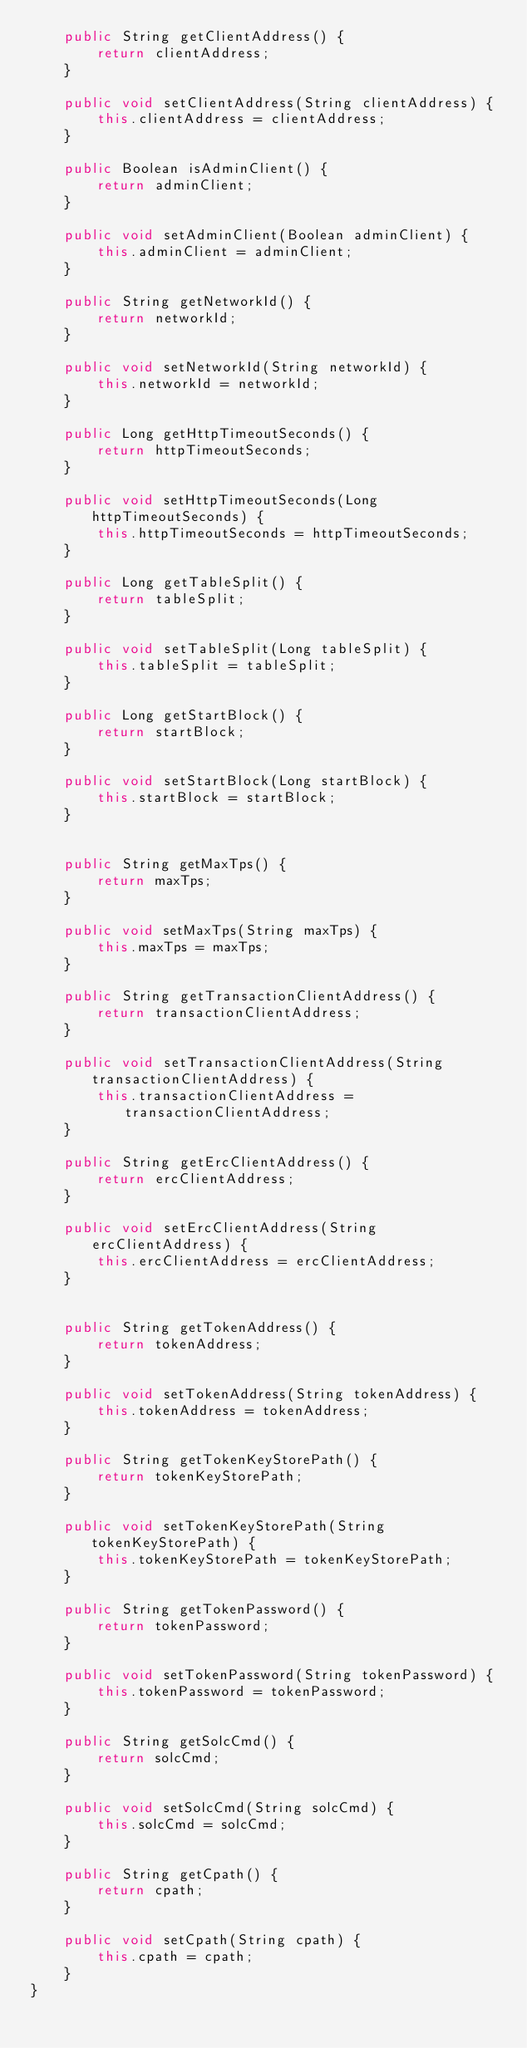<code> <loc_0><loc_0><loc_500><loc_500><_Java_>    public String getClientAddress() {
        return clientAddress;
    }

    public void setClientAddress(String clientAddress) {
        this.clientAddress = clientAddress;
    }

    public Boolean isAdminClient() {
        return adminClient;
    }

    public void setAdminClient(Boolean adminClient) {
        this.adminClient = adminClient;
    }

    public String getNetworkId() {
        return networkId;
    }

    public void setNetworkId(String networkId) {
        this.networkId = networkId;
    }

    public Long getHttpTimeoutSeconds() {
        return httpTimeoutSeconds;
    }

    public void setHttpTimeoutSeconds(Long httpTimeoutSeconds) {
        this.httpTimeoutSeconds = httpTimeoutSeconds;
    }

    public Long getTableSplit() {
        return tableSplit;
    }

    public void setTableSplit(Long tableSplit) {
        this.tableSplit = tableSplit;
    }

    public Long getStartBlock() {
        return startBlock;
    }

    public void setStartBlock(Long startBlock) {
        this.startBlock = startBlock;
    }


    public String getMaxTps() {
        return maxTps;
    }

    public void setMaxTps(String maxTps) {
        this.maxTps = maxTps;
    }

    public String getTransactionClientAddress() {
        return transactionClientAddress;
    }

    public void setTransactionClientAddress(String transactionClientAddress) {
        this.transactionClientAddress = transactionClientAddress;
    }

    public String getErcClientAddress() {
        return ercClientAddress;
    }

    public void setErcClientAddress(String ercClientAddress) {
        this.ercClientAddress = ercClientAddress;
    }


    public String getTokenAddress() {
        return tokenAddress;
    }

    public void setTokenAddress(String tokenAddress) {
        this.tokenAddress = tokenAddress;
    }

    public String getTokenKeyStorePath() {
        return tokenKeyStorePath;
    }

    public void setTokenKeyStorePath(String tokenKeyStorePath) {
        this.tokenKeyStorePath = tokenKeyStorePath;
    }

    public String getTokenPassword() {
        return tokenPassword;
    }

    public void setTokenPassword(String tokenPassword) {
        this.tokenPassword = tokenPassword;
    }

    public String getSolcCmd() {
        return solcCmd;
    }

    public void setSolcCmd(String solcCmd) {
        this.solcCmd = solcCmd;
    }

    public String getCpath() {
        return cpath;
    }

    public void setCpath(String cpath) {
        this.cpath = cpath;
    }
}
</code> 